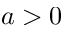<formula> <loc_0><loc_0><loc_500><loc_500>a > 0</formula> 